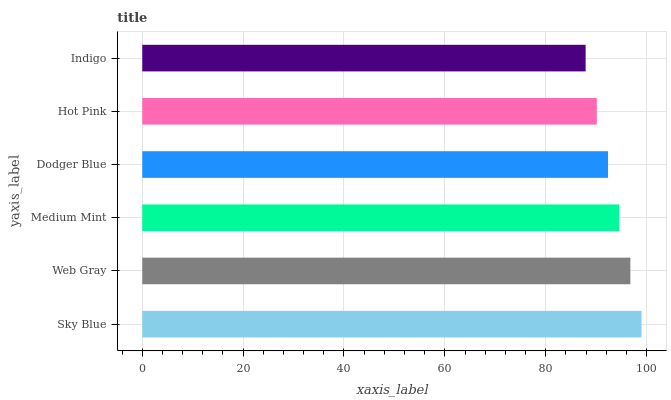Is Indigo the minimum?
Answer yes or no. Yes. Is Sky Blue the maximum?
Answer yes or no. Yes. Is Web Gray the minimum?
Answer yes or no. No. Is Web Gray the maximum?
Answer yes or no. No. Is Sky Blue greater than Web Gray?
Answer yes or no. Yes. Is Web Gray less than Sky Blue?
Answer yes or no. Yes. Is Web Gray greater than Sky Blue?
Answer yes or no. No. Is Sky Blue less than Web Gray?
Answer yes or no. No. Is Medium Mint the high median?
Answer yes or no. Yes. Is Dodger Blue the low median?
Answer yes or no. Yes. Is Indigo the high median?
Answer yes or no. No. Is Web Gray the low median?
Answer yes or no. No. 